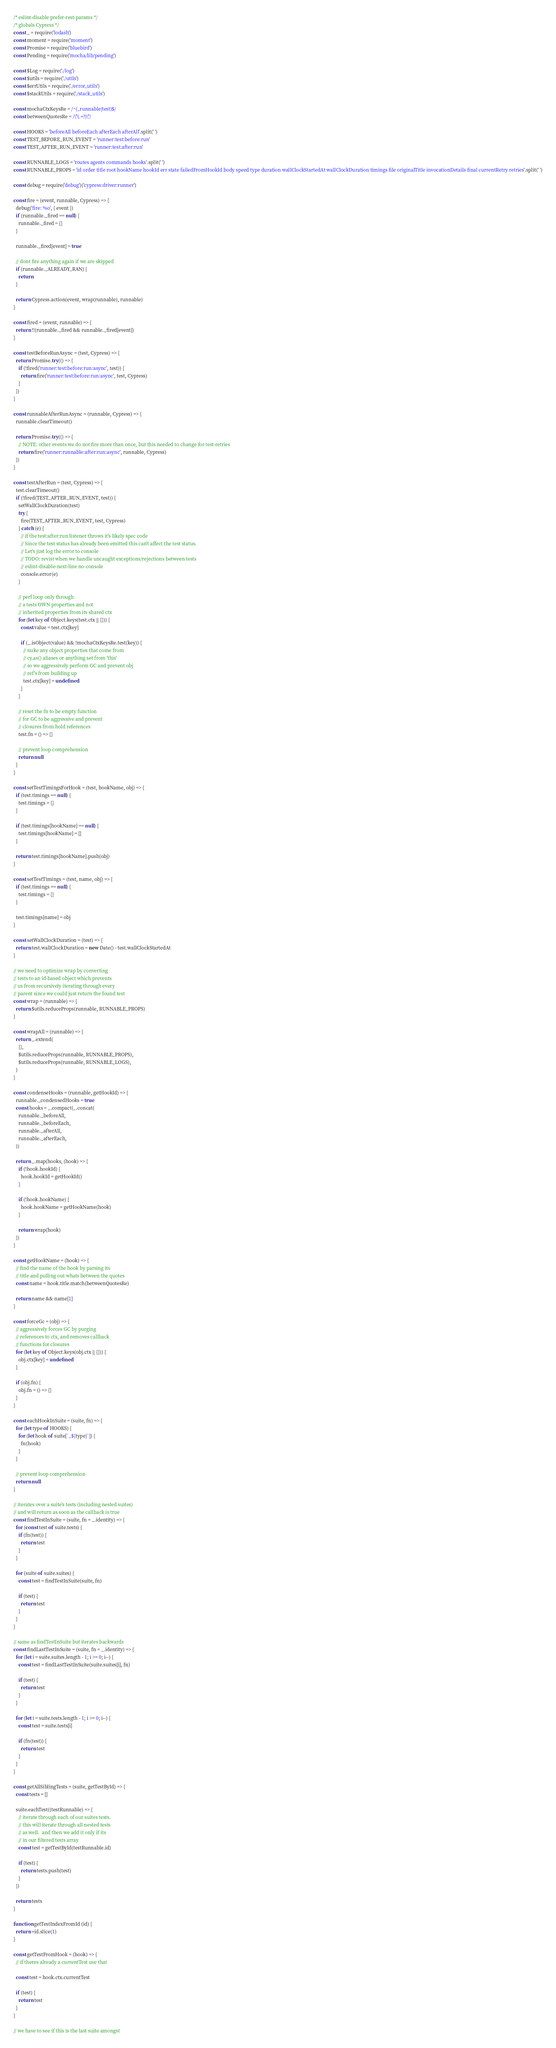<code> <loc_0><loc_0><loc_500><loc_500><_JavaScript_>/* eslint-disable prefer-rest-params */
/* globals Cypress */
const _ = require('lodash')
const moment = require('moment')
const Promise = require('bluebird')
const Pending = require('mocha/lib/pending')

const $Log = require('./log')
const $utils = require('./utils')
const $errUtils = require('./error_utils')
const $stackUtils = require('./stack_utils')

const mochaCtxKeysRe = /^(_runnable|test)$/
const betweenQuotesRe = /\"(.+?)\"/

const HOOKS = 'beforeAll beforeEach afterEach afterAll'.split(' ')
const TEST_BEFORE_RUN_EVENT = 'runner:test:before:run'
const TEST_AFTER_RUN_EVENT = 'runner:test:after:run'

const RUNNABLE_LOGS = 'routes agents commands hooks'.split(' ')
const RUNNABLE_PROPS = 'id order title root hookName hookId err state failedFromHookId body speed type duration wallClockStartedAt wallClockDuration timings file originalTitle invocationDetails final currentRetry retries'.split(' ')

const debug = require('debug')('cypress:driver:runner')

const fire = (event, runnable, Cypress) => {
  debug('fire: %o', { event })
  if (runnable._fired == null) {
    runnable._fired = {}
  }

  runnable._fired[event] = true

  // dont fire anything again if we are skipped
  if (runnable._ALREADY_RAN) {
    return
  }

  return Cypress.action(event, wrap(runnable), runnable)
}

const fired = (event, runnable) => {
  return !!(runnable._fired && runnable._fired[event])
}

const testBeforeRunAsync = (test, Cypress) => {
  return Promise.try(() => {
    if (!fired('runner:test:before:run:async', test)) {
      return fire('runner:test:before:run:async', test, Cypress)
    }
  })
}

const runnableAfterRunAsync = (runnable, Cypress) => {
  runnable.clearTimeout()

  return Promise.try(() => {
    // NOTE: other events we do not fire more than once, but this needed to change for test-retries
    return fire('runner:runnable:after:run:async', runnable, Cypress)
  })
}

const testAfterRun = (test, Cypress) => {
  test.clearTimeout()
  if (!fired(TEST_AFTER_RUN_EVENT, test)) {
    setWallClockDuration(test)
    try {
      fire(TEST_AFTER_RUN_EVENT, test, Cypress)
    } catch (e) {
      // if the test:after:run listener throws it's likely spec code
      // Since the test status has already been emitted this can't affect the test status.
      // Let's just log the error to console
      // TODO: revist when we handle uncaught exceptions/rejections between tests
      // eslint-disable-next-line no-console
      console.error(e)
    }

    // perf loop only through
    // a tests OWN properties and not
    // inherited properties from its shared ctx
    for (let key of Object.keys(test.ctx || {})) {
      const value = test.ctx[key]

      if (_.isObject(value) && !mochaCtxKeysRe.test(key)) {
        // nuke any object properties that come from
        // cy.as() aliases or anything set from 'this'
        // so we aggressively perform GC and prevent obj
        // ref's from building up
        test.ctx[key] = undefined
      }
    }

    // reset the fn to be empty function
    // for GC to be aggressive and prevent
    // closures from hold references
    test.fn = () => {}

    // prevent loop comprehension
    return null
  }
}

const setTestTimingsForHook = (test, hookName, obj) => {
  if (test.timings == null) {
    test.timings = {}
  }

  if (test.timings[hookName] == null) {
    test.timings[hookName] = []
  }

  return test.timings[hookName].push(obj)
}

const setTestTimings = (test, name, obj) => {
  if (test.timings == null) {
    test.timings = {}
  }

  test.timings[name] = obj
}

const setWallClockDuration = (test) => {
  return test.wallClockDuration = new Date() - test.wallClockStartedAt
}

// we need to optimize wrap by converting
// tests to an id-based object which prevents
// us from recursively iterating through every
// parent since we could just return the found test
const wrap = (runnable) => {
  return $utils.reduceProps(runnable, RUNNABLE_PROPS)
}

const wrapAll = (runnable) => {
  return _.extend(
    {},
    $utils.reduceProps(runnable, RUNNABLE_PROPS),
    $utils.reduceProps(runnable, RUNNABLE_LOGS),
  )
}

const condenseHooks = (runnable, getHookId) => {
  runnable._condensedHooks = true
  const hooks = _.compact(_.concat(
    runnable._beforeAll,
    runnable._beforeEach,
    runnable._afterAll,
    runnable._afterEach,
  ))

  return _.map(hooks, (hook) => {
    if (!hook.hookId) {
      hook.hookId = getHookId()
    }

    if (!hook.hookName) {
      hook.hookName = getHookName(hook)
    }

    return wrap(hook)
  })
}

const getHookName = (hook) => {
  // find the name of the hook by parsing its
  // title and pulling out whats between the quotes
  const name = hook.title.match(betweenQuotesRe)

  return name && name[1]
}

const forceGc = (obj) => {
  // aggressively forces GC by purging
  // references to ctx, and removes callback
  // functions for closures
  for (let key of Object.keys(obj.ctx || {})) {
    obj.ctx[key] = undefined
  }

  if (obj.fn) {
    obj.fn = () => {}
  }
}

const eachHookInSuite = (suite, fn) => {
  for (let type of HOOKS) {
    for (let hook of suite[`_${type}`]) {
      fn(hook)
    }
  }

  // prevent loop comprehension
  return null
}

// iterates over a suite's tests (including nested suites)
// and will return as soon as the callback is true
const findTestInSuite = (suite, fn = _.identity) => {
  for (const test of suite.tests) {
    if (fn(test)) {
      return test
    }
  }

  for (suite of suite.suites) {
    const test = findTestInSuite(suite, fn)

    if (test) {
      return test
    }
  }
}

// same as findTestInSuite but iterates backwards
const findLastTestInSuite = (suite, fn = _.identity) => {
  for (let i = suite.suites.length - 1; i >= 0; i--) {
    const test = findLastTestInSuite(suite.suites[i], fn)

    if (test) {
      return test
    }
  }

  for (let i = suite.tests.length - 1; i >= 0; i--) {
    const test = suite.tests[i]

    if (fn(test)) {
      return test
    }
  }
}

const getAllSiblingTests = (suite, getTestById) => {
  const tests = []

  suite.eachTest((testRunnable) => {
    // iterate through each of our suites tests.
    // this will iterate through all nested tests
    // as well.  and then we add it only if its
    // in our filtered tests array
    const test = getTestById(testRunnable.id)

    if (test) {
      return tests.push(test)
    }
  })

  return tests
}

function getTestIndexFromId (id) {
  return +id.slice(1)
}

const getTestFromHook = (hook) => {
  // if theres already a currentTest use that

  const test = hook.ctx.currentTest

  if (test) {
    return test
  }
}

// we have to see if this is the last suite amongst</code> 